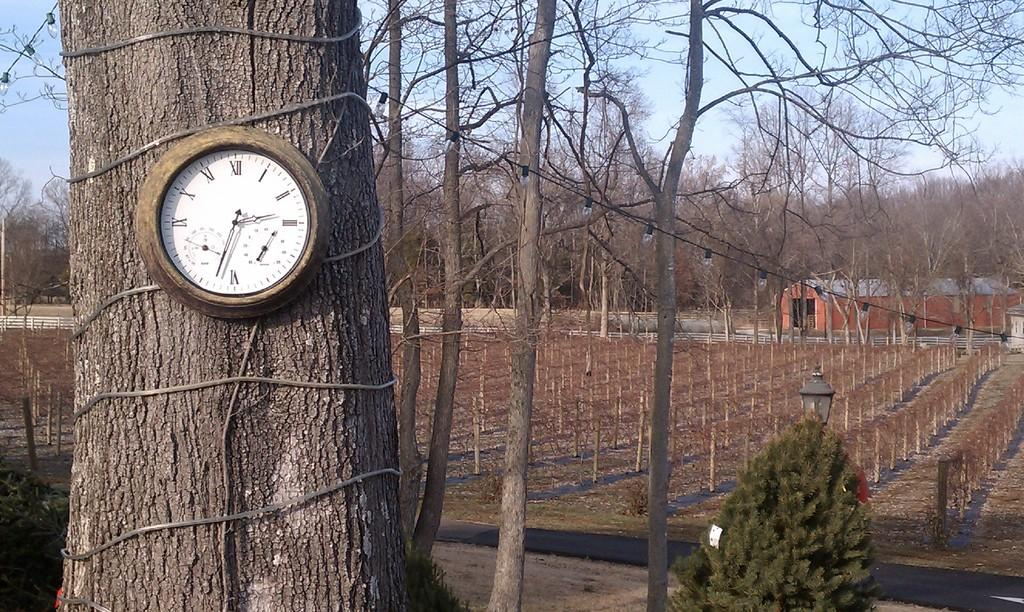<image>
Summarize the visual content of the image. a clock on a tree says that it is 2:37 